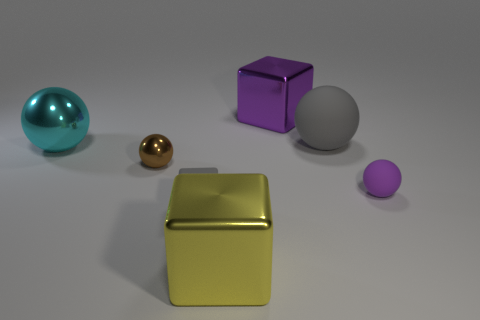Subtract all large purple blocks. How many blocks are left? 2 Add 2 small brown shiny balls. How many objects exist? 9 Subtract all balls. How many objects are left? 3 Subtract 2 balls. How many balls are left? 2 Add 7 purple objects. How many purple objects are left? 9 Add 3 big blue rubber cubes. How many big blue rubber cubes exist? 3 Subtract all brown balls. How many balls are left? 3 Subtract 1 gray cubes. How many objects are left? 6 Subtract all purple spheres. Subtract all cyan cylinders. How many spheres are left? 3 Subtract all gray cylinders. Subtract all large balls. How many objects are left? 5 